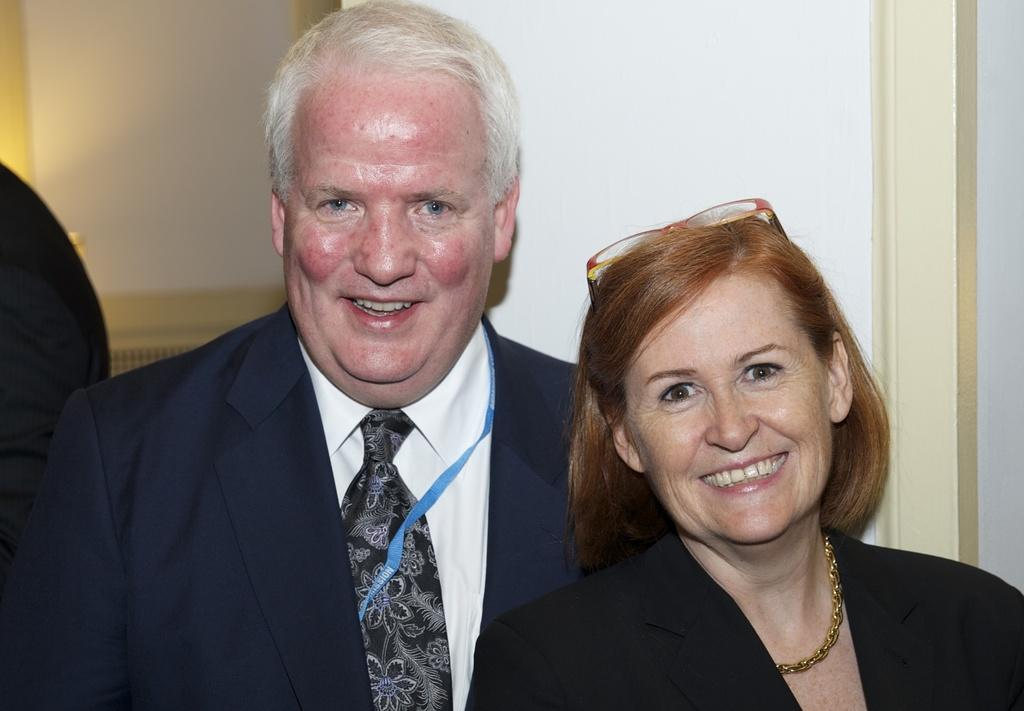What is the expression on the man's face in the image? The man is smiling in the image. What is the expression on the woman's face in the image? The woman is also smiling in the image. What can be seen in the background of the image? There is a wall in the background of the image. What type of crown is the man wearing in the image? There is no crown present in the image; neither the man nor the woman is wearing one. 